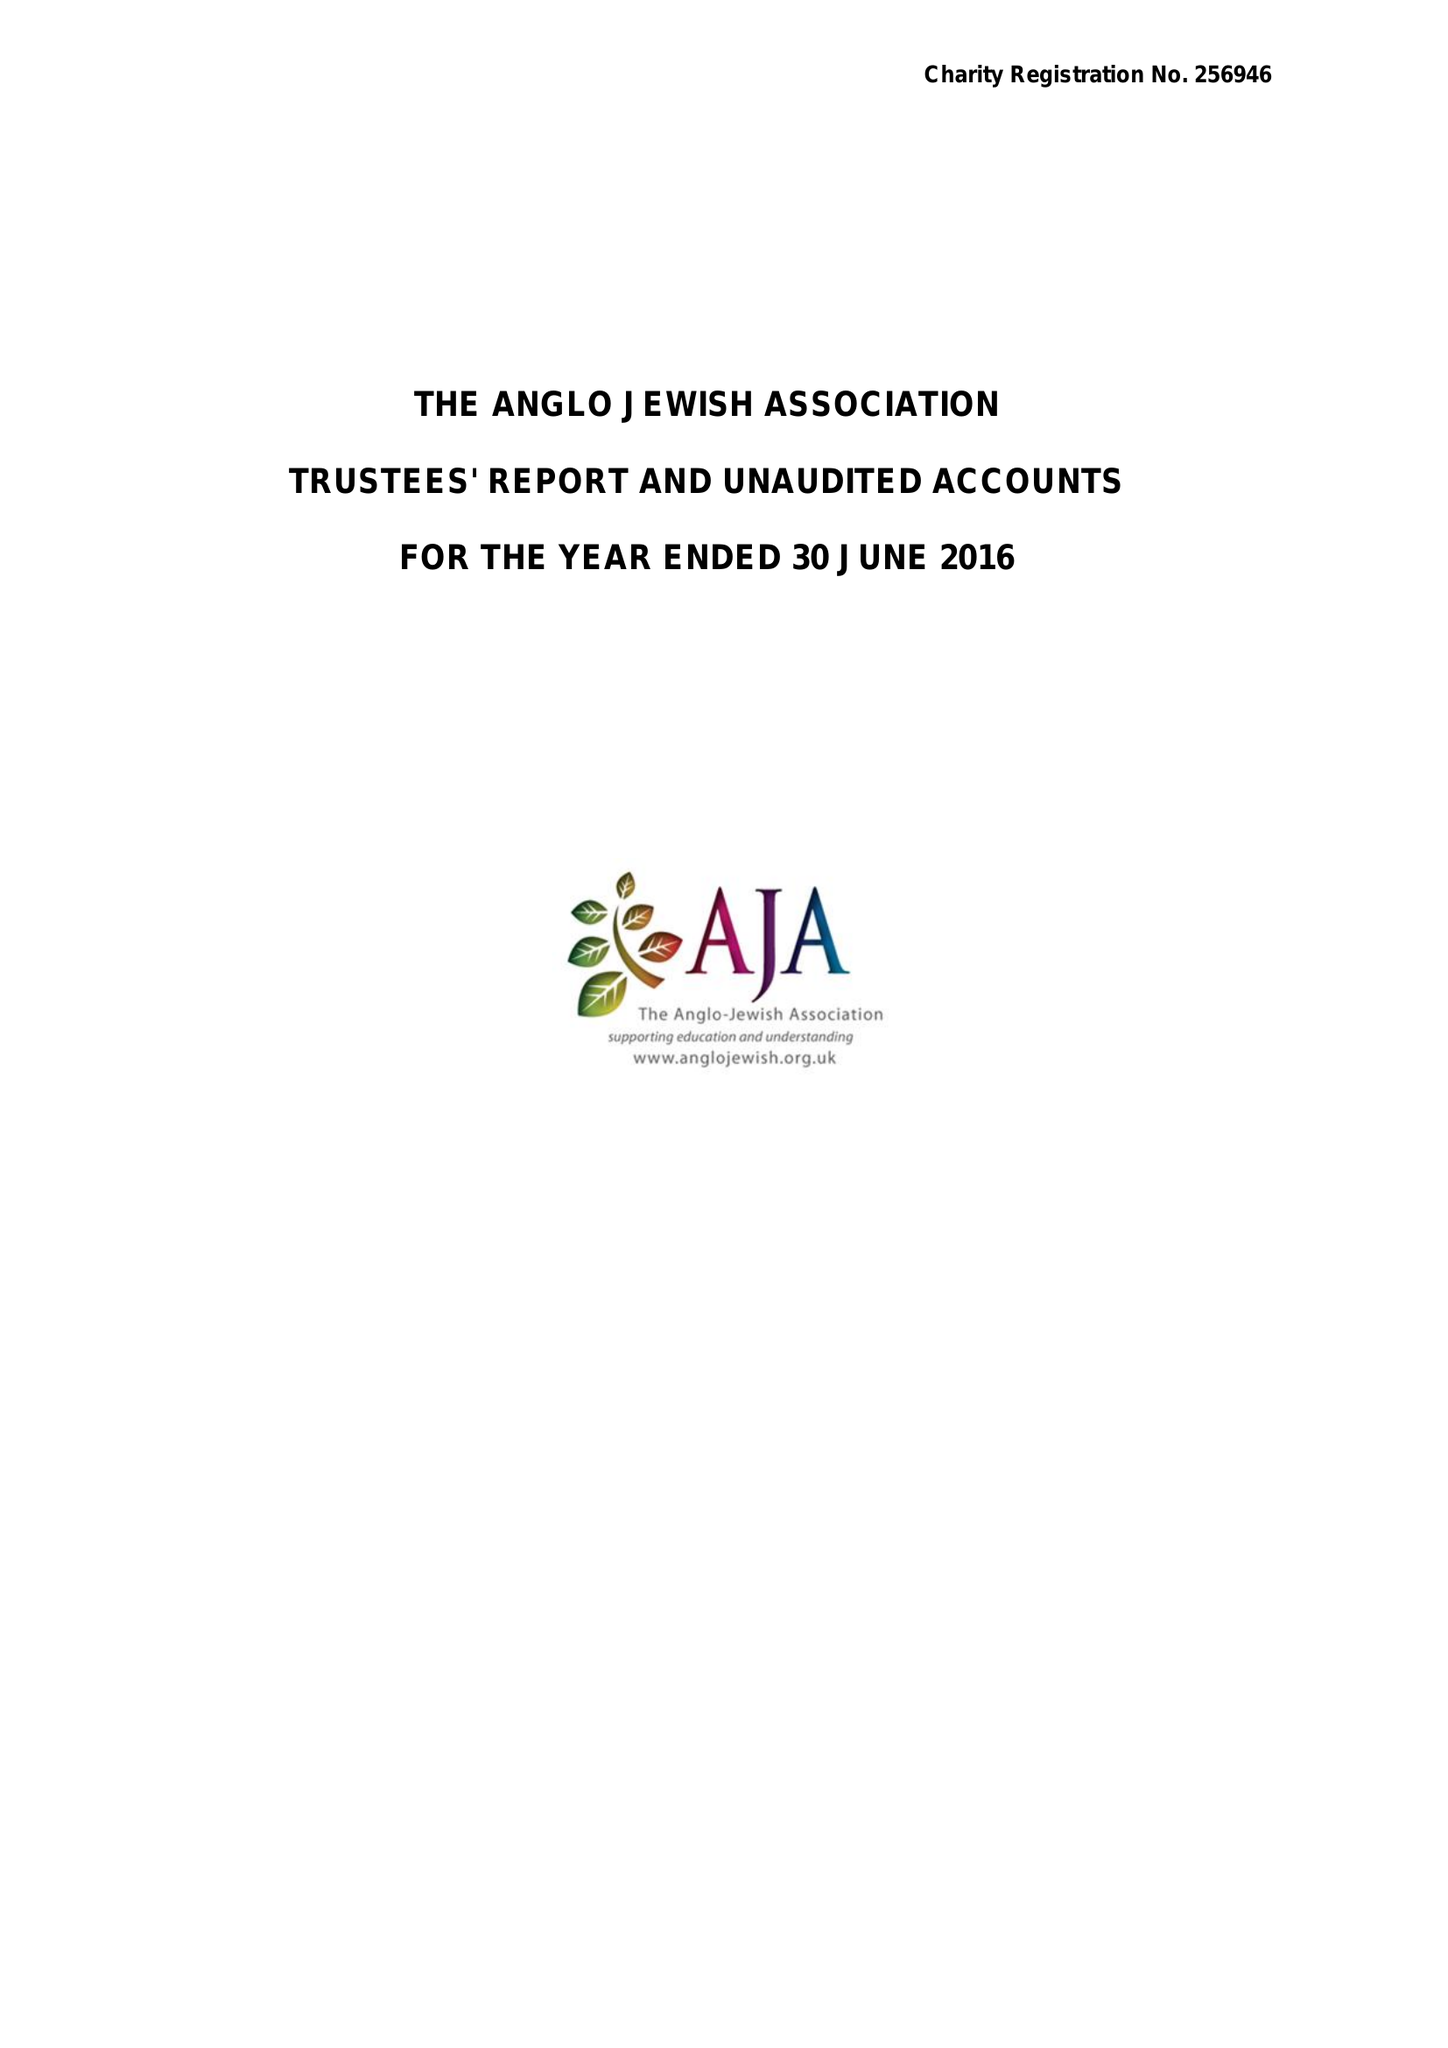What is the value for the report_date?
Answer the question using a single word or phrase. 2016-06-30 